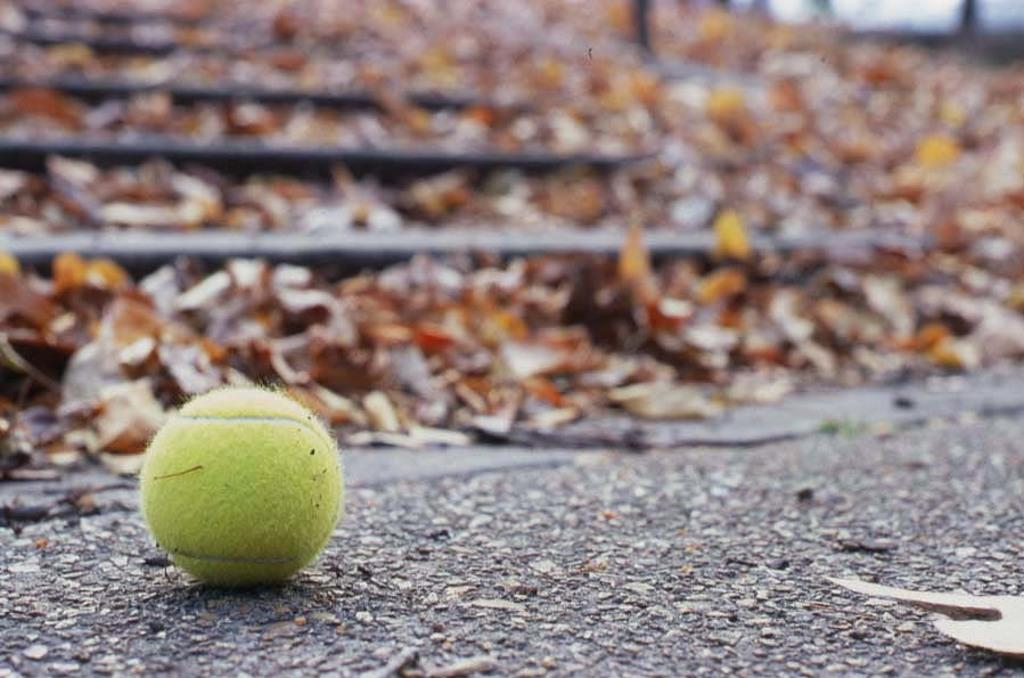Where was the picture taken? The picture was clicked outside. What can be seen on the ground in the image? There is a green color ball on the ground. What type of vegetation can be seen in the background? Dry leaves are visible in the background. Can you describe any other objects or features in the background? There are other unspecified objects in the background. What type of smell can be detected from the green color ball in the image? There is no information about the smell of the green color ball in the image, as it is a visual medium. 